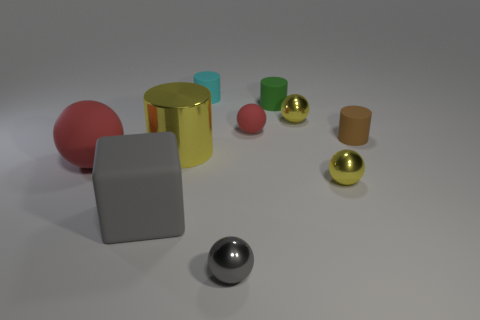Subtract all blue blocks. Subtract all blue cylinders. How many blocks are left? 1 Subtract all blocks. How many objects are left? 9 Subtract all metallic cylinders. Subtract all gray objects. How many objects are left? 7 Add 4 tiny green rubber cylinders. How many tiny green rubber cylinders are left? 5 Add 2 green rubber balls. How many green rubber balls exist? 2 Subtract 0 blue cylinders. How many objects are left? 10 